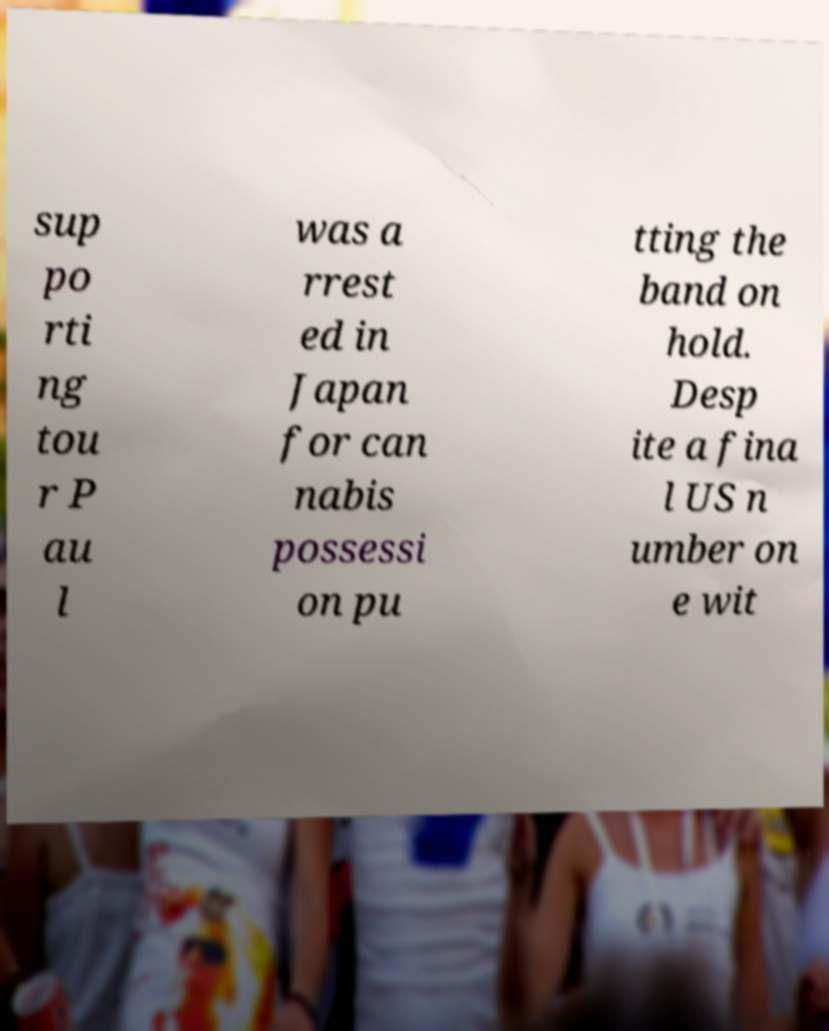For documentation purposes, I need the text within this image transcribed. Could you provide that? sup po rti ng tou r P au l was a rrest ed in Japan for can nabis possessi on pu tting the band on hold. Desp ite a fina l US n umber on e wit 